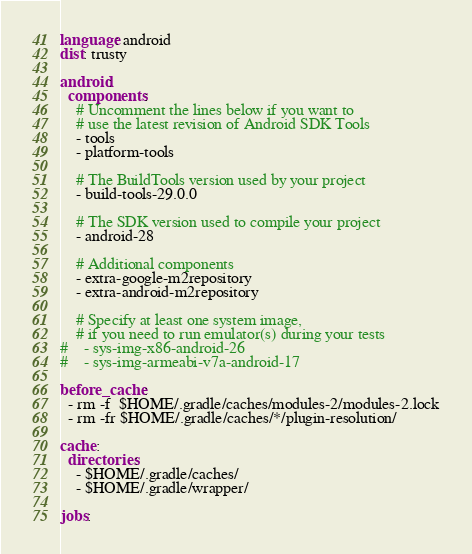Convert code to text. <code><loc_0><loc_0><loc_500><loc_500><_YAML_>language: android
dist: trusty

android:
  components:
    # Uncomment the lines below if you want to
    # use the latest revision of Android SDK Tools
    - tools
    - platform-tools

    # The BuildTools version used by your project
    - build-tools-29.0.0

    # The SDK version used to compile your project
    - android-28

    # Additional components
    - extra-google-m2repository
    - extra-android-m2repository

    # Specify at least one system image,
    # if you need to run emulator(s) during your tests
#    - sys-img-x86-android-26
#    - sys-img-armeabi-v7a-android-17

before_cache:
  - rm -f  $HOME/.gradle/caches/modules-2/modules-2.lock
  - rm -fr $HOME/.gradle/caches/*/plugin-resolution/

cache:
  directories:
    - $HOME/.gradle/caches/
    - $HOME/.gradle/wrapper/

jobs:</code> 